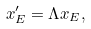<formula> <loc_0><loc_0><loc_500><loc_500>x ^ { \prime } _ { E } = \Lambda x _ { E } ,</formula> 